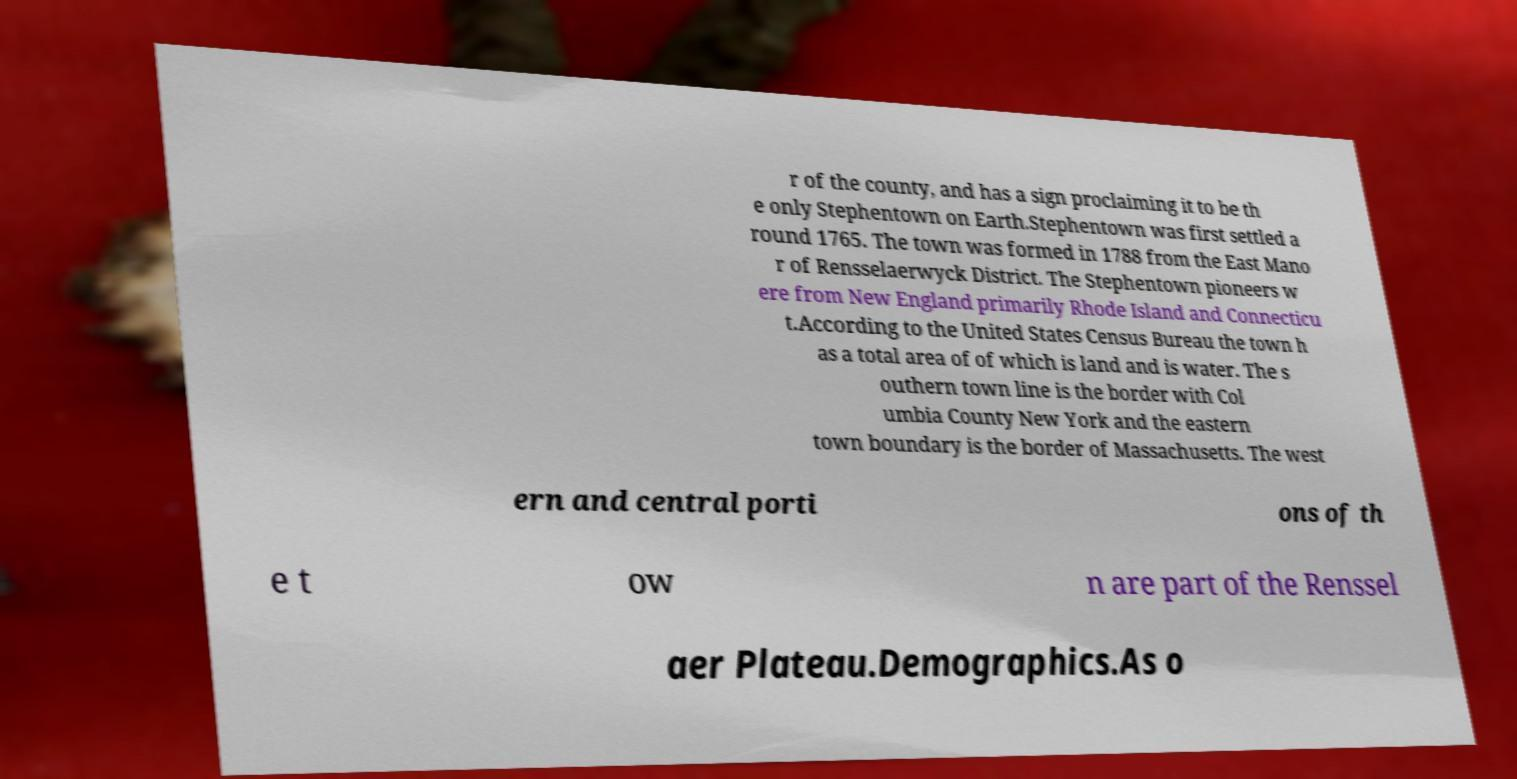Please read and relay the text visible in this image. What does it say? r of the county, and has a sign proclaiming it to be th e only Stephentown on Earth.Stephentown was first settled a round 1765. The town was formed in 1788 from the East Mano r of Rensselaerwyck District. The Stephentown pioneers w ere from New England primarily Rhode Island and Connecticu t.According to the United States Census Bureau the town h as a total area of of which is land and is water. The s outhern town line is the border with Col umbia County New York and the eastern town boundary is the border of Massachusetts. The west ern and central porti ons of th e t ow n are part of the Renssel aer Plateau.Demographics.As o 